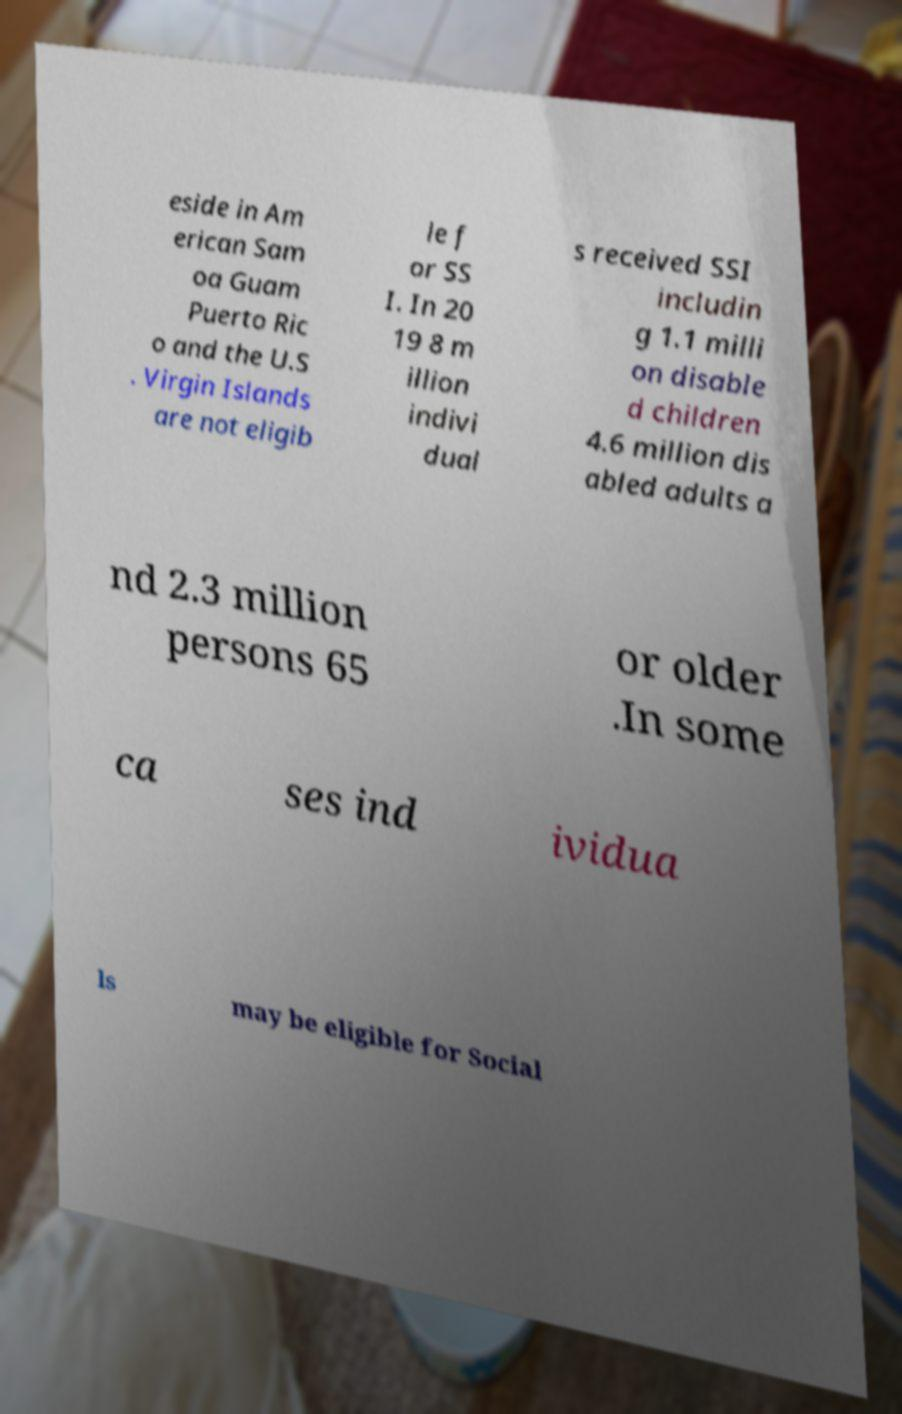Can you accurately transcribe the text from the provided image for me? eside in Am erican Sam oa Guam Puerto Ric o and the U.S . Virgin Islands are not eligib le f or SS I. In 20 19 8 m illion indivi dual s received SSI includin g 1.1 milli on disable d children 4.6 million dis abled adults a nd 2.3 million persons 65 or older .In some ca ses ind ividua ls may be eligible for Social 